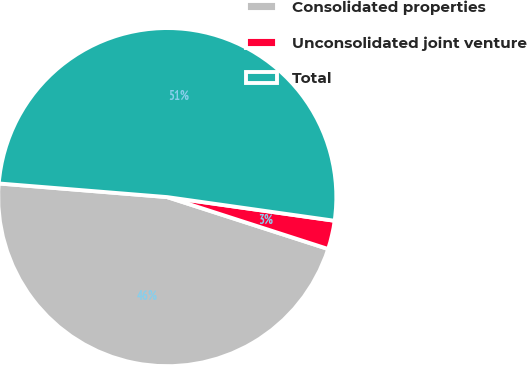<chart> <loc_0><loc_0><loc_500><loc_500><pie_chart><fcel>Consolidated properties<fcel>Unconsolidated joint venture<fcel>Total<nl><fcel>46.32%<fcel>2.73%<fcel>50.95%<nl></chart> 